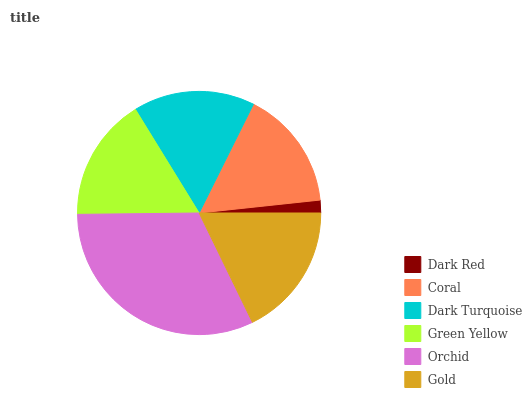Is Dark Red the minimum?
Answer yes or no. Yes. Is Orchid the maximum?
Answer yes or no. Yes. Is Coral the minimum?
Answer yes or no. No. Is Coral the maximum?
Answer yes or no. No. Is Coral greater than Dark Red?
Answer yes or no. Yes. Is Dark Red less than Coral?
Answer yes or no. Yes. Is Dark Red greater than Coral?
Answer yes or no. No. Is Coral less than Dark Red?
Answer yes or no. No. Is Green Yellow the high median?
Answer yes or no. Yes. Is Dark Turquoise the low median?
Answer yes or no. Yes. Is Dark Turquoise the high median?
Answer yes or no. No. Is Green Yellow the low median?
Answer yes or no. No. 